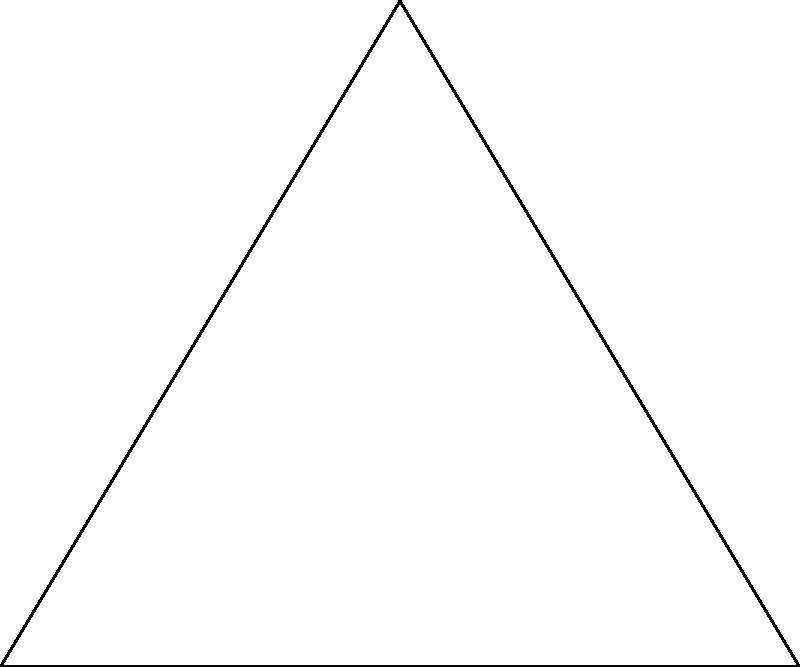You're planning to spray pesticide around a triangular house to eliminate toads. The spray nozzle creates a circular pattern with a 2-meter radius. If you spray from each corner of the house (points A, B, and C), what is the total area covered by the pesticide, rounded to the nearest square meter? The house has sides of length 6m, 6m, and 5m. To solve this problem, we need to follow these steps:

1) First, calculate the area of a single circular spray pattern:
   Area of circle = $\pi r^2 = \pi (2m)^2 = 4\pi$ m²

2) Calculate the total area of three circles:
   $3 * 4\pi = 12\pi$ m²

3) However, this includes overlapping areas. We need to calculate the area of the triangle to subtract the overlaps:
   Area of triangle = $\frac{1}{2} * base * height$
   $height = \sqrt{6^2 - 3^2} = \sqrt{27} = 3\sqrt{3}$ m
   Area = $\frac{1}{2} * 6 * 3\sqrt{3} = 9\sqrt{3}$ m²

4) The area we want is the area of the three circles minus twice the area of the triangle (because each overlap is counted twice in the total circle area):
   Effective area = $12\pi - 2(9\sqrt{3})$ m²

5) Calculate this value:
   $12\pi - 18\sqrt{3} \approx 37.70$ m²

6) Rounding to the nearest square meter:
   38 m²
Answer: 38 m² 